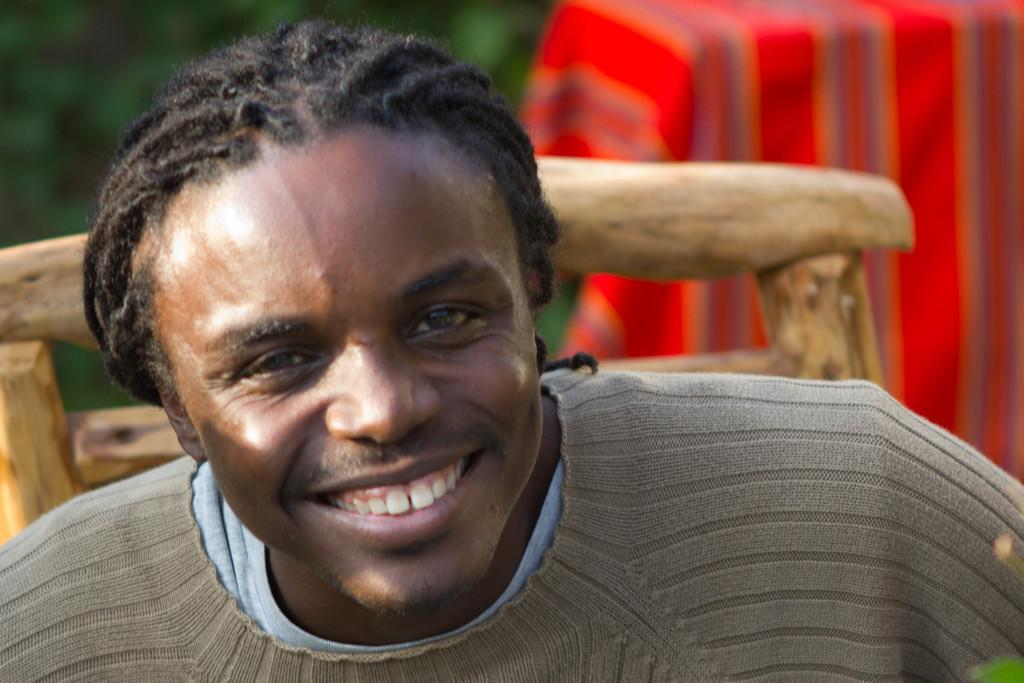Who is present in the image? There is a man in the image. What is the man's facial expression? The man is smiling. What type of clothing is the man wearing? The man is wearing a sweater. What can be seen in the background of the image? There is a wooden chair in the background of the image. What type of beast is the man interacting with in the image? There is no beast present in the image; it features a man smiling and wearing a sweater. What day of the week is depicted in the image? The image does not depict a specific day of the week; it only shows a man smiling and wearing a sweater. 